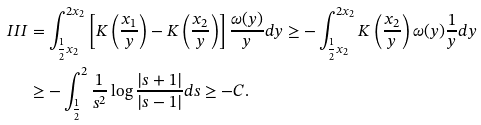<formula> <loc_0><loc_0><loc_500><loc_500>I I I & = \int _ { \frac { 1 } { 2 } x _ { 2 } } ^ { 2 x _ { 2 } } \left [ K \left ( \frac { x _ { 1 } } { y } \right ) - K \left ( \frac { x _ { 2 } } { y } \right ) \right ] \frac { \omega ( y ) } { y } d y \geq - \int _ { \frac { 1 } { 2 } x _ { 2 } } ^ { 2 x _ { 2 } } K \left ( \frac { x _ { 2 } } { y } \right ) \omega ( y ) \frac { 1 } { y } d y \\ & \geq - \int _ { \frac { 1 } { 2 } } ^ { 2 } \frac { 1 } { s ^ { 2 } } \log \frac { | s + 1 | } { | s - 1 | } d s \geq - C .</formula> 